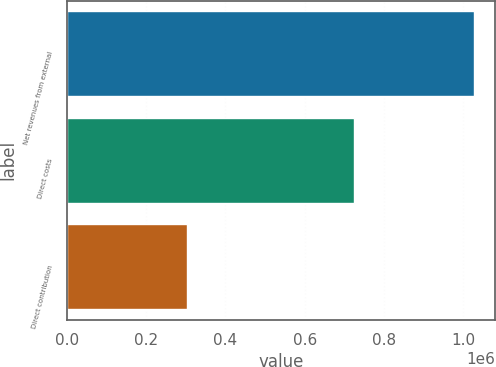Convert chart. <chart><loc_0><loc_0><loc_500><loc_500><bar_chart><fcel>Net revenues from external<fcel>Direct costs<fcel>Direct contribution<nl><fcel>1.02846e+06<fcel>725616<fcel>302839<nl></chart> 